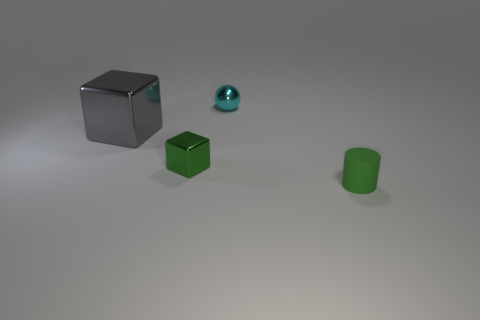Add 4 rubber things. How many objects exist? 8 Subtract all balls. How many objects are left? 3 Add 4 cyan objects. How many cyan objects are left? 5 Add 4 tiny cylinders. How many tiny cylinders exist? 5 Subtract 0 cyan cylinders. How many objects are left? 4 Subtract all small shiny blocks. Subtract all small blocks. How many objects are left? 2 